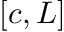<formula> <loc_0><loc_0><loc_500><loc_500>[ c , L ]</formula> 